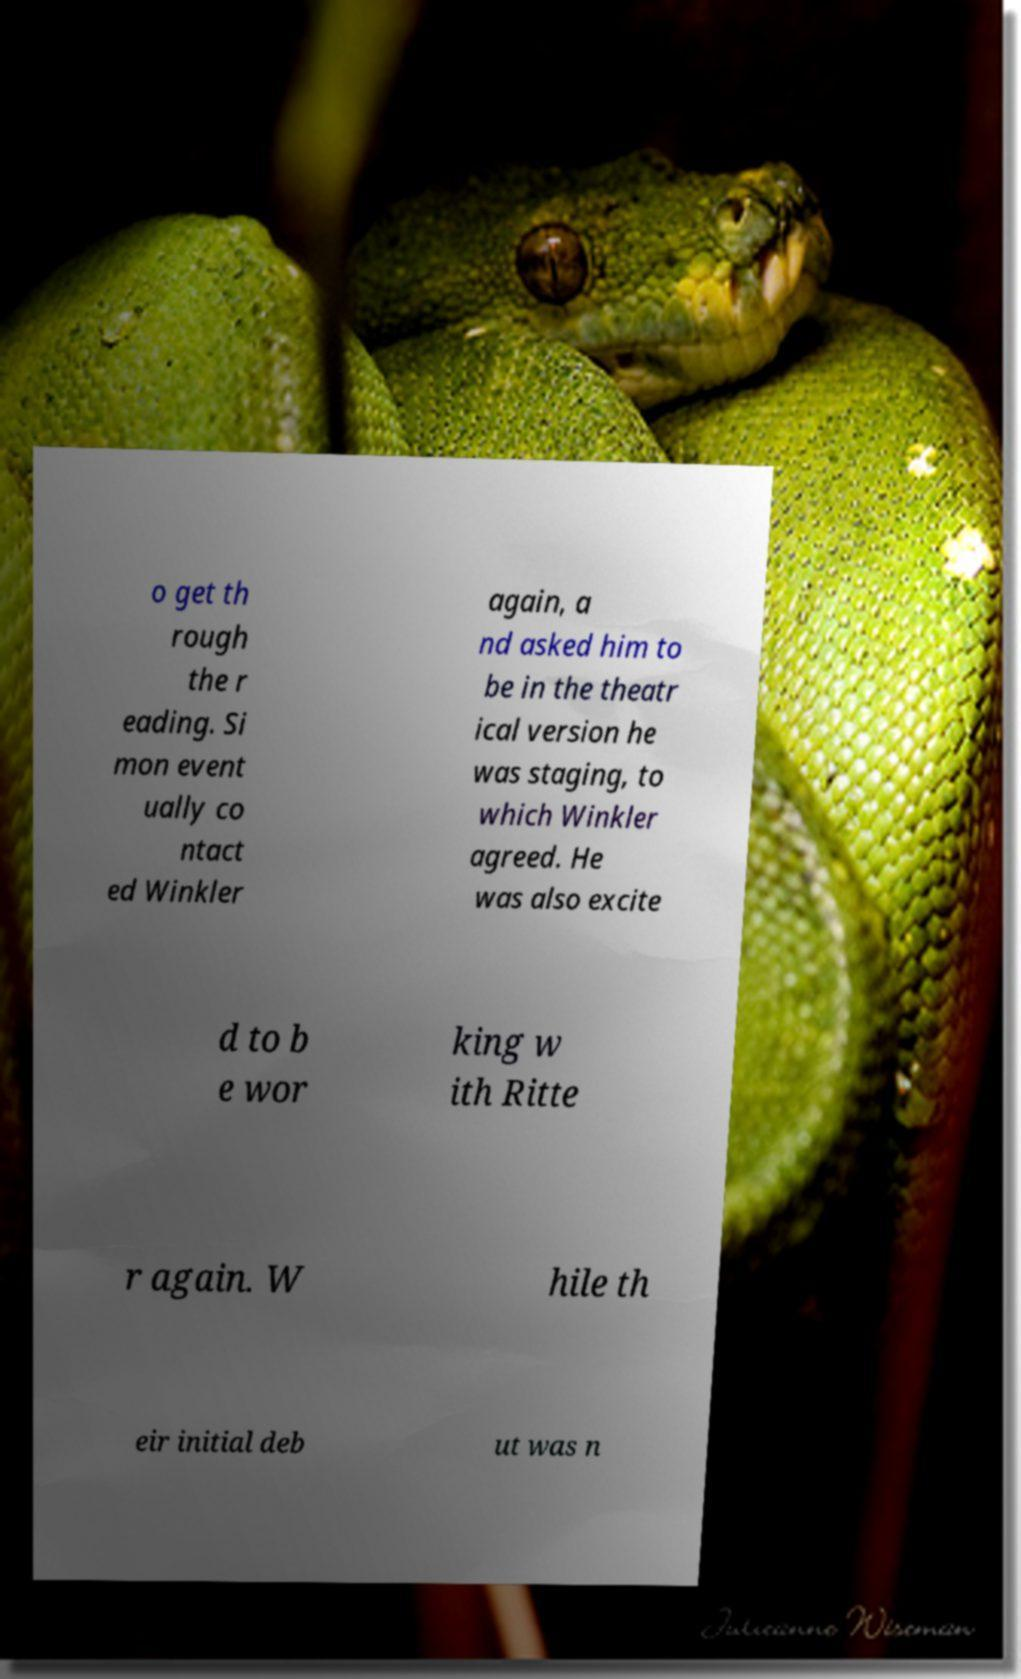Could you assist in decoding the text presented in this image and type it out clearly? o get th rough the r eading. Si mon event ually co ntact ed Winkler again, a nd asked him to be in the theatr ical version he was staging, to which Winkler agreed. He was also excite d to b e wor king w ith Ritte r again. W hile th eir initial deb ut was n 